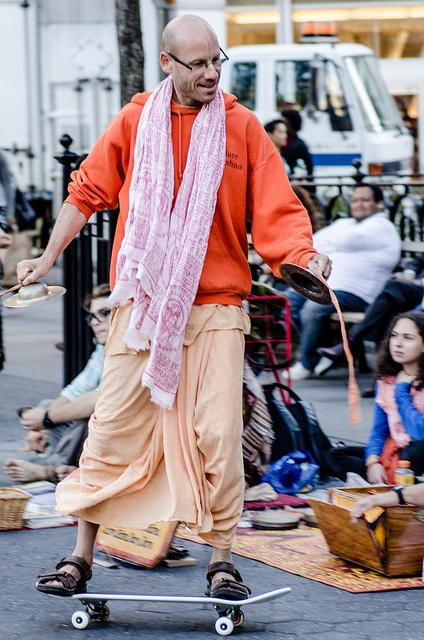In what year was his organization founded in New York City?

Choices:
A) 1929
B) 1902
C) 1945
D) 1966 1966 